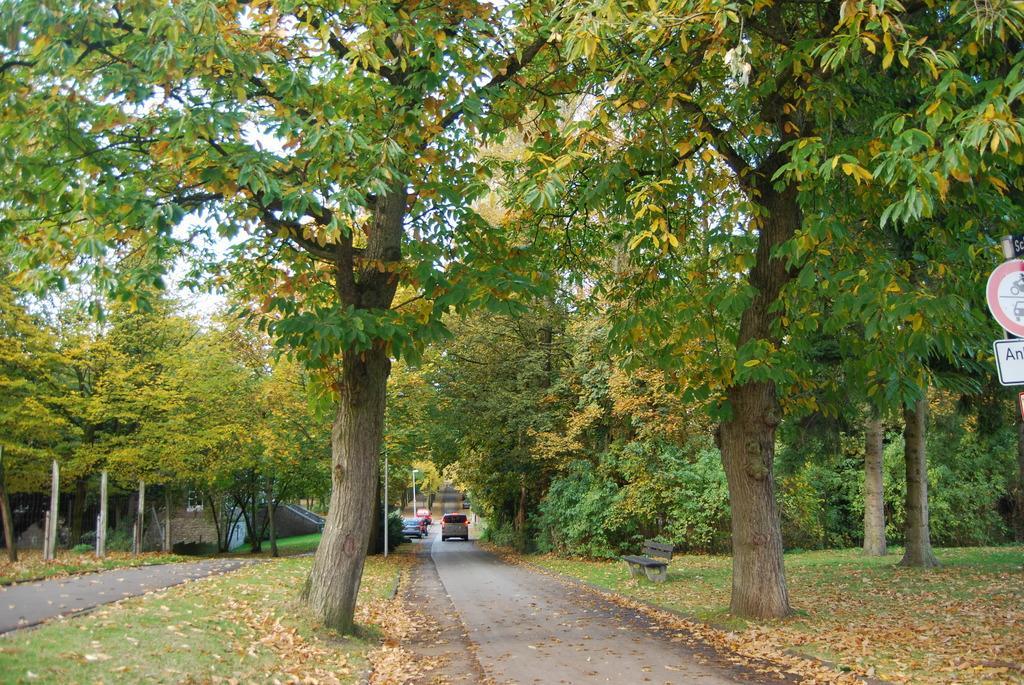In one or two sentences, can you explain what this image depicts? There are some cars on the road as we can see at the bottom of this image. There are some trees in the background. There is a table and a sign board on the right side of this image. 